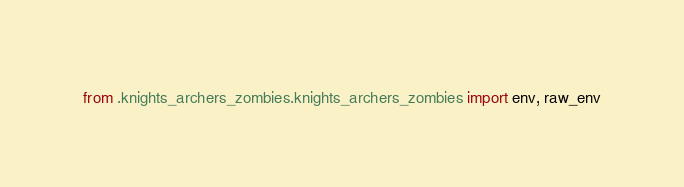<code> <loc_0><loc_0><loc_500><loc_500><_Python_>from .knights_archers_zombies.knights_archers_zombies import env, raw_env
</code> 